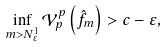Convert formula to latex. <formula><loc_0><loc_0><loc_500><loc_500>\inf _ { m > N _ { \varepsilon } ^ { 1 } } \mathcal { V } _ { p } ^ { p } \left ( \hat { f } _ { m } \right ) > c - \varepsilon ,</formula> 